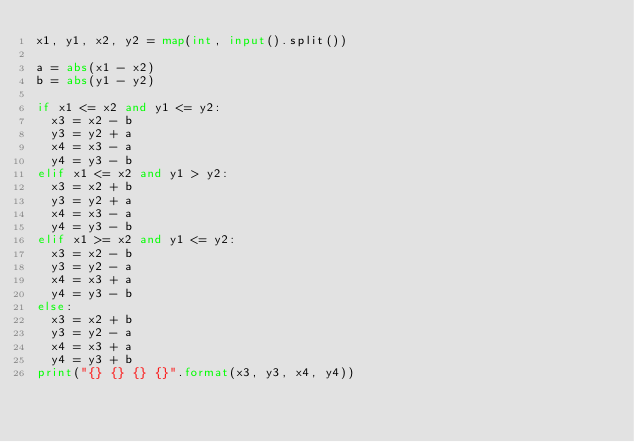<code> <loc_0><loc_0><loc_500><loc_500><_Python_>x1, y1, x2, y2 = map(int, input().split())

a = abs(x1 - x2)
b = abs(y1 - y2)

if x1 <= x2 and y1 <= y2:
  x3 = x2 - b
  y3 = y2 + a
  x4 = x3 - a
  y4 = y3 - b
elif x1 <= x2 and y1 > y2:
  x3 = x2 + b
  y3 = y2 + a
  x4 = x3 - a
  y4 = y3 - b
elif x1 >= x2 and y1 <= y2:
  x3 = x2 - b
  y3 = y2 - a
  x4 = x3 + a
  y4 = y3 - b
else:
  x3 = x2 + b
  y3 = y2 - a
  x4 = x3 + a
  y4 = y3 + b
print("{} {} {} {}".format(x3, y3, x4, y4))</code> 